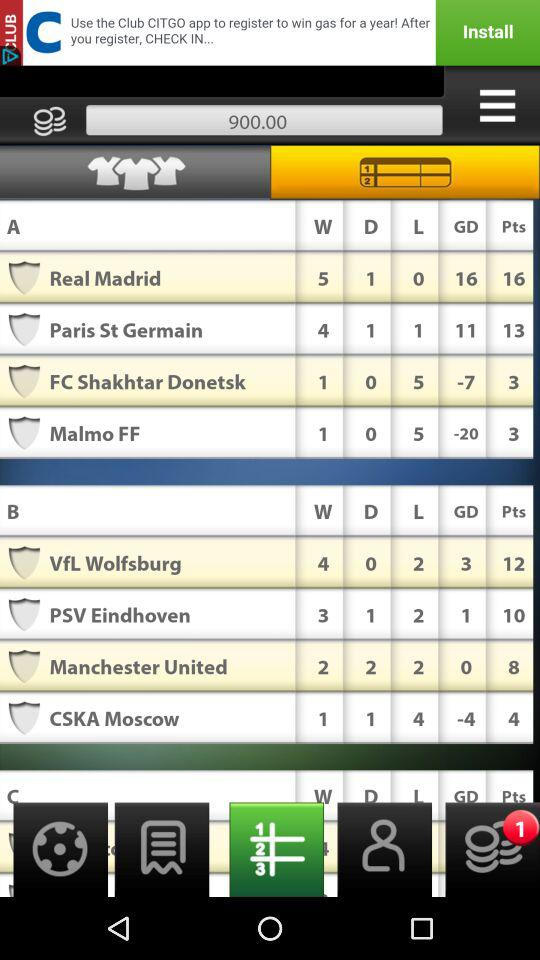How many total points does PSV Eindhoven have? PSV Eindhoven has 10 points. 